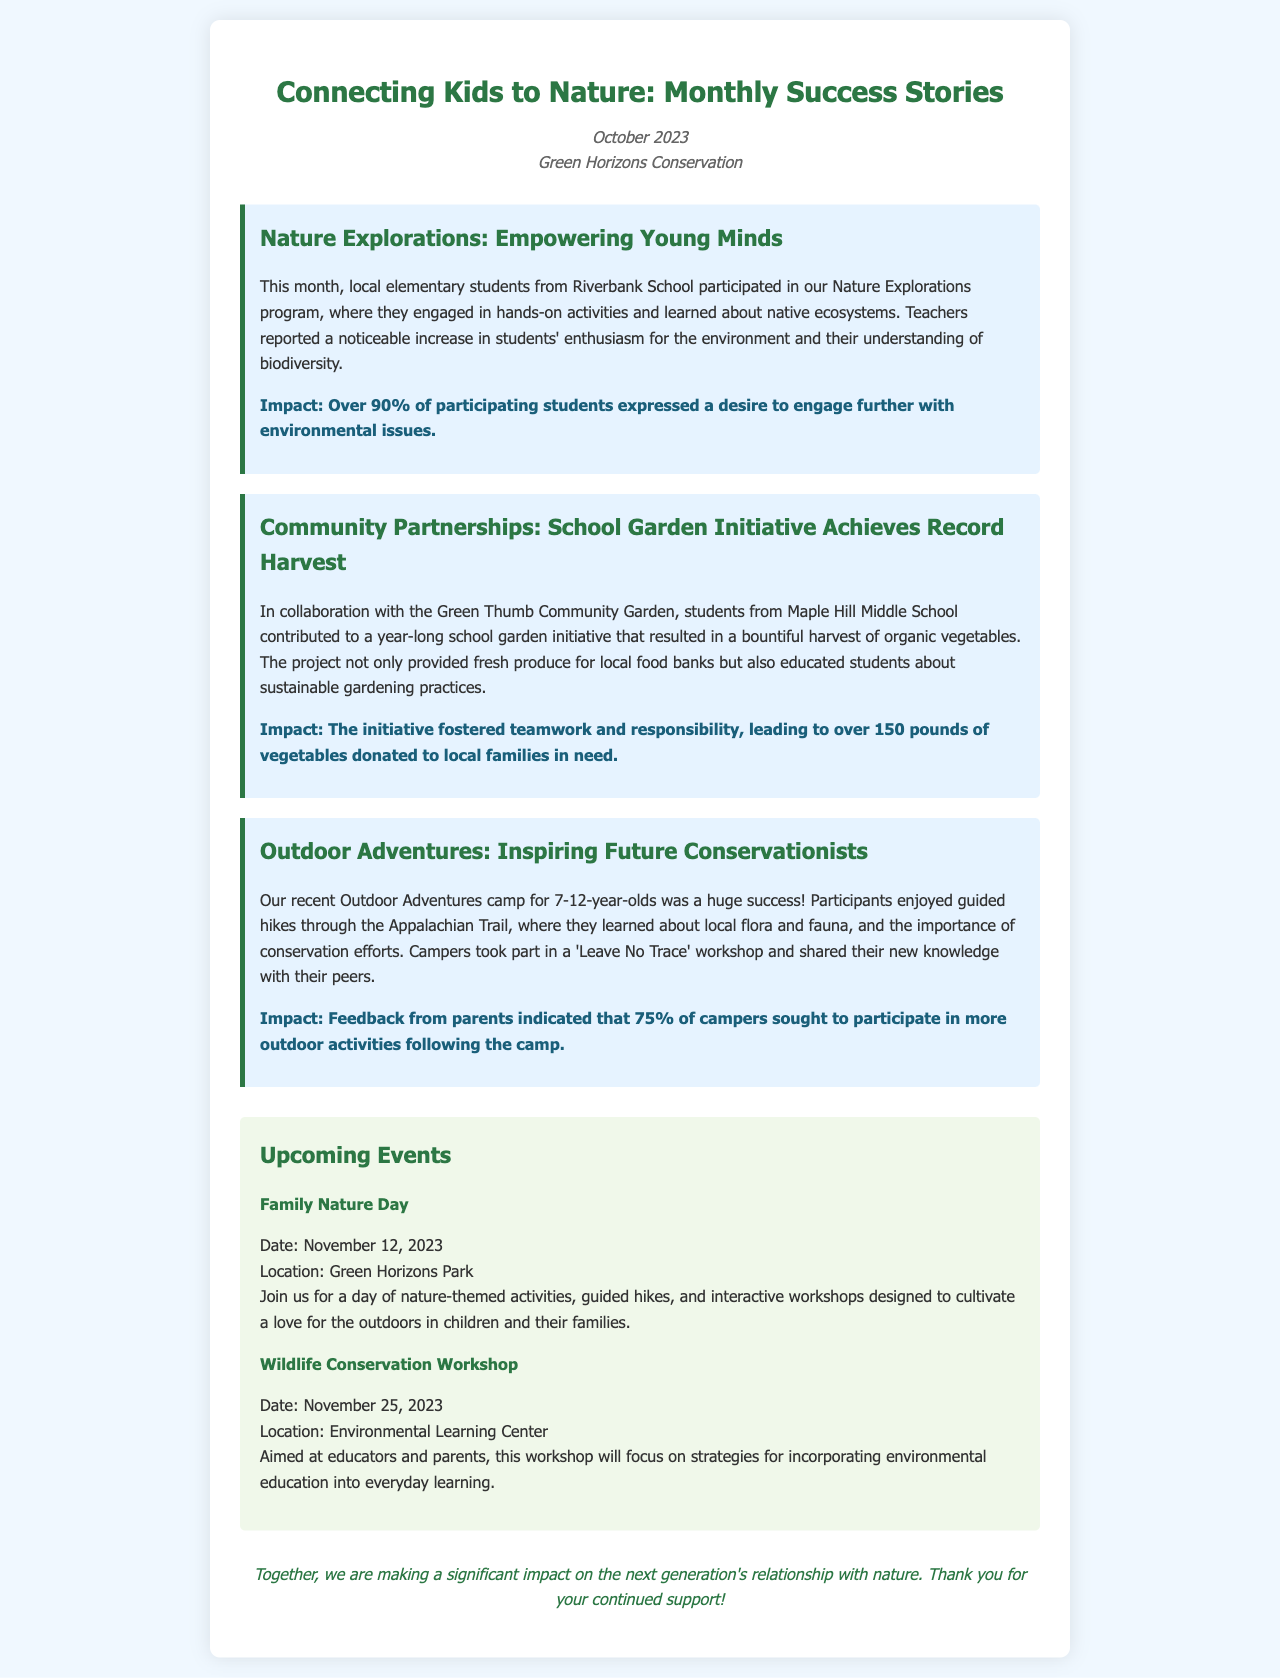what is the title of the newsletter? The title of the newsletter is stated at the top of the document.
Answer: Connecting Kids to Nature: Monthly Success Stories what organization is sending the newsletter? The name of the organization is mentioned in the header of the document.
Answer: Green Horizons Conservation when was the Nature Explorations program held? The date is not explicitly stated, but the newsletter is for October 2023, so it likely occurred in that month.
Answer: October 2023 what percentage of students expressed a desire to engage further with environmental issues? This percentage is noted in the impact section of the Nature Explorations initiative.
Answer: Over 90% how many pounds of vegetables were donated from the school garden initiative? The amount is specified in the impact section related to the school garden initiative.
Answer: Over 150 pounds what is the date of the Family Nature Day event? The date for this event is provided in the upcoming events section.
Answer: November 12, 2023 where is the Wildlife Conservation Workshop taking place? The location is mentioned in the details of the upcoming event.
Answer: Environmental Learning Center what is one of the activities campers participated in at the Outdoor Adventures camp? This information can be found in the description of the Outdoor Adventures camp.
Answer: Guided hikes what was the main focus of the Wildlife Conservation Workshop? The focus is indicated in the description of the event.
Answer: Incorporating environmental education into everyday learning 